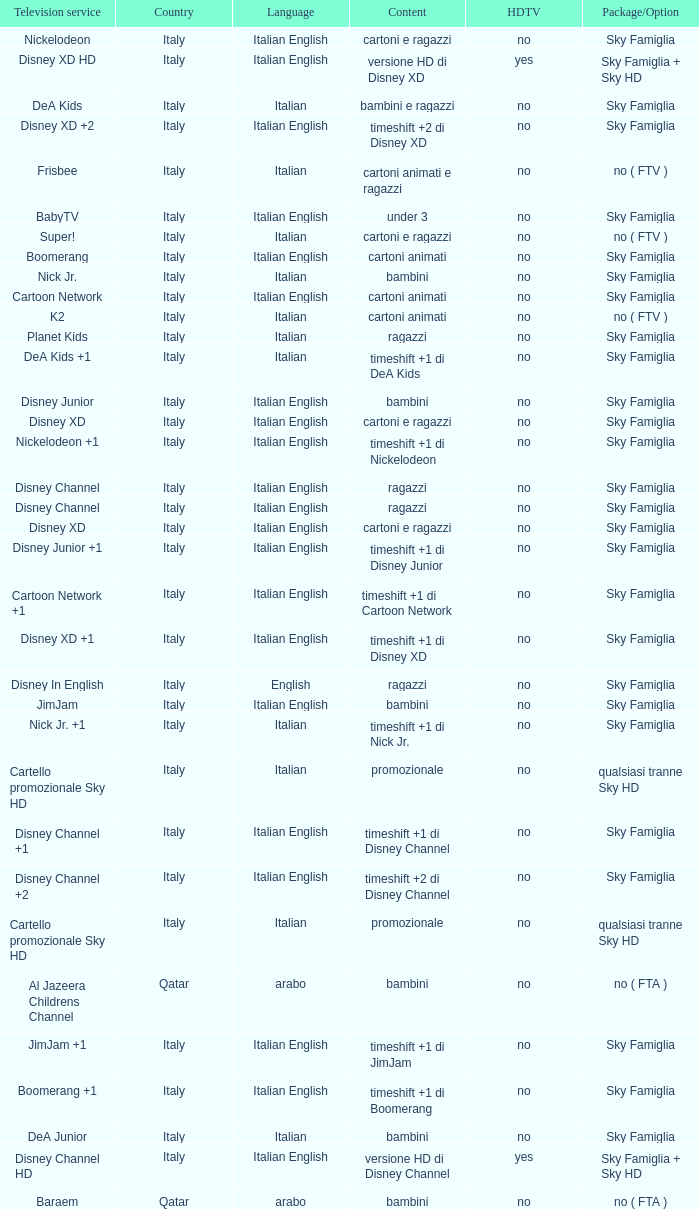What is the HDTV when the Package/Option is sky famiglia, and a Television service of boomerang +1? No. 